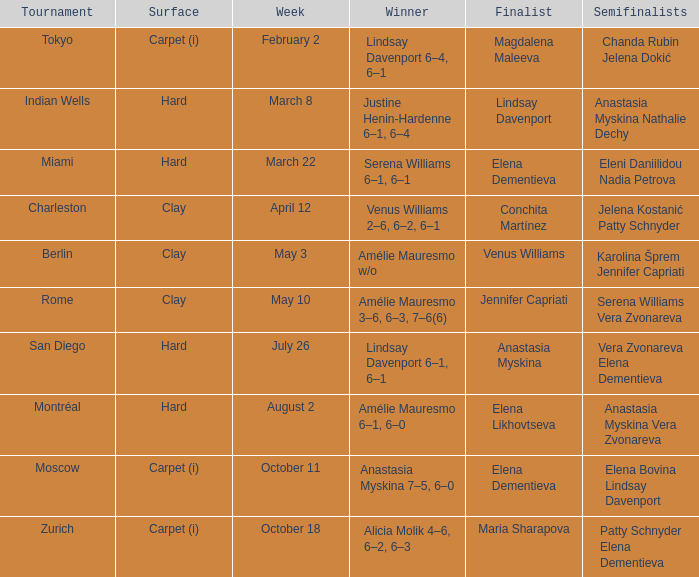Who secured the win in the miami tournament that featured elena dementieva as a finalist? Serena Williams 6–1, 6–1. 